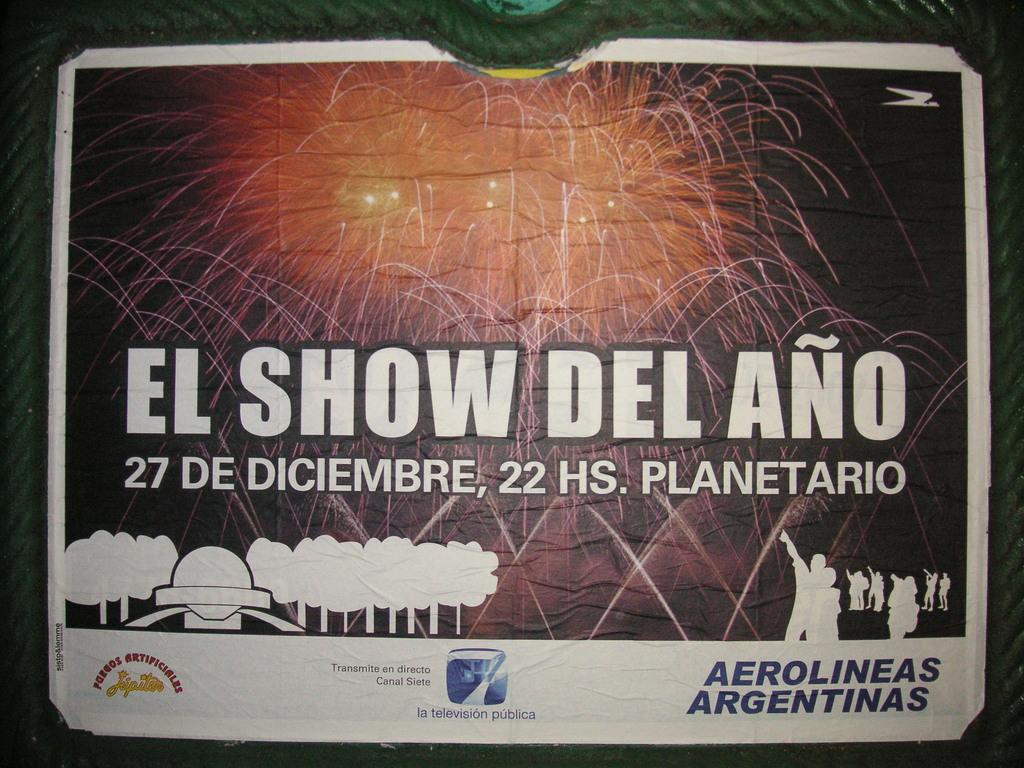<image>
Provide a brief description of the given image. a page on a surface that says 'el show del ano' on it 